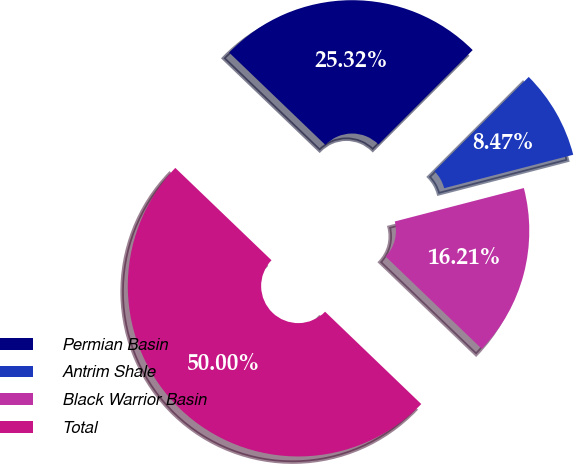Convert chart. <chart><loc_0><loc_0><loc_500><loc_500><pie_chart><fcel>Permian Basin<fcel>Antrim Shale<fcel>Black Warrior Basin<fcel>Total<nl><fcel>25.32%<fcel>8.47%<fcel>16.21%<fcel>50.0%<nl></chart> 